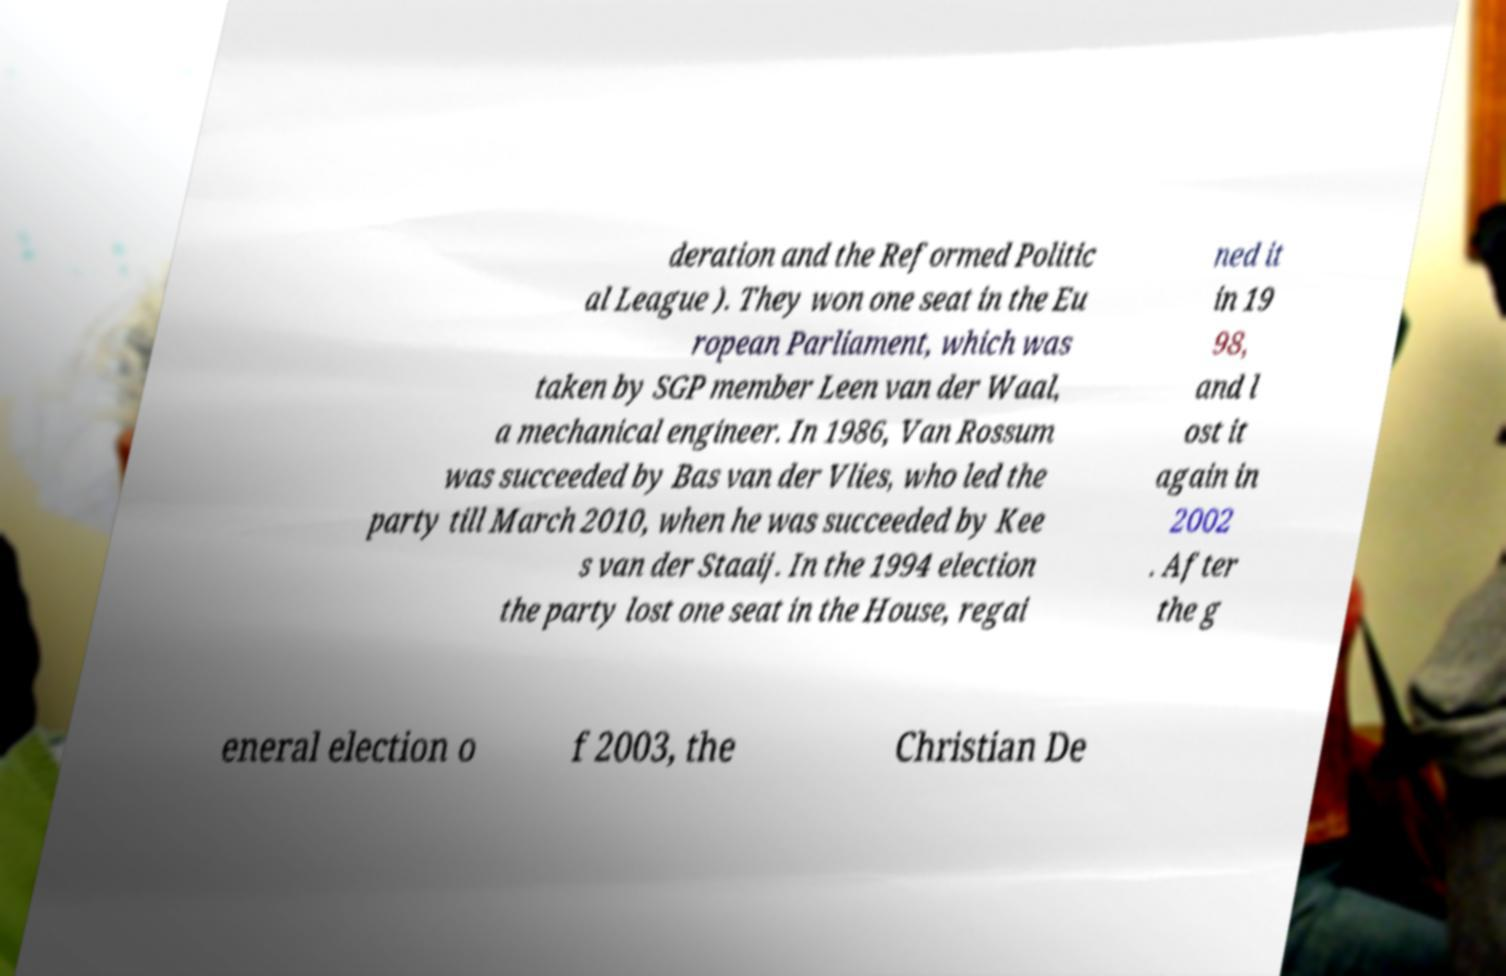I need the written content from this picture converted into text. Can you do that? deration and the Reformed Politic al League ). They won one seat in the Eu ropean Parliament, which was taken by SGP member Leen van der Waal, a mechanical engineer. In 1986, Van Rossum was succeeded by Bas van der Vlies, who led the party till March 2010, when he was succeeded by Kee s van der Staaij. In the 1994 election the party lost one seat in the House, regai ned it in 19 98, and l ost it again in 2002 . After the g eneral election o f 2003, the Christian De 